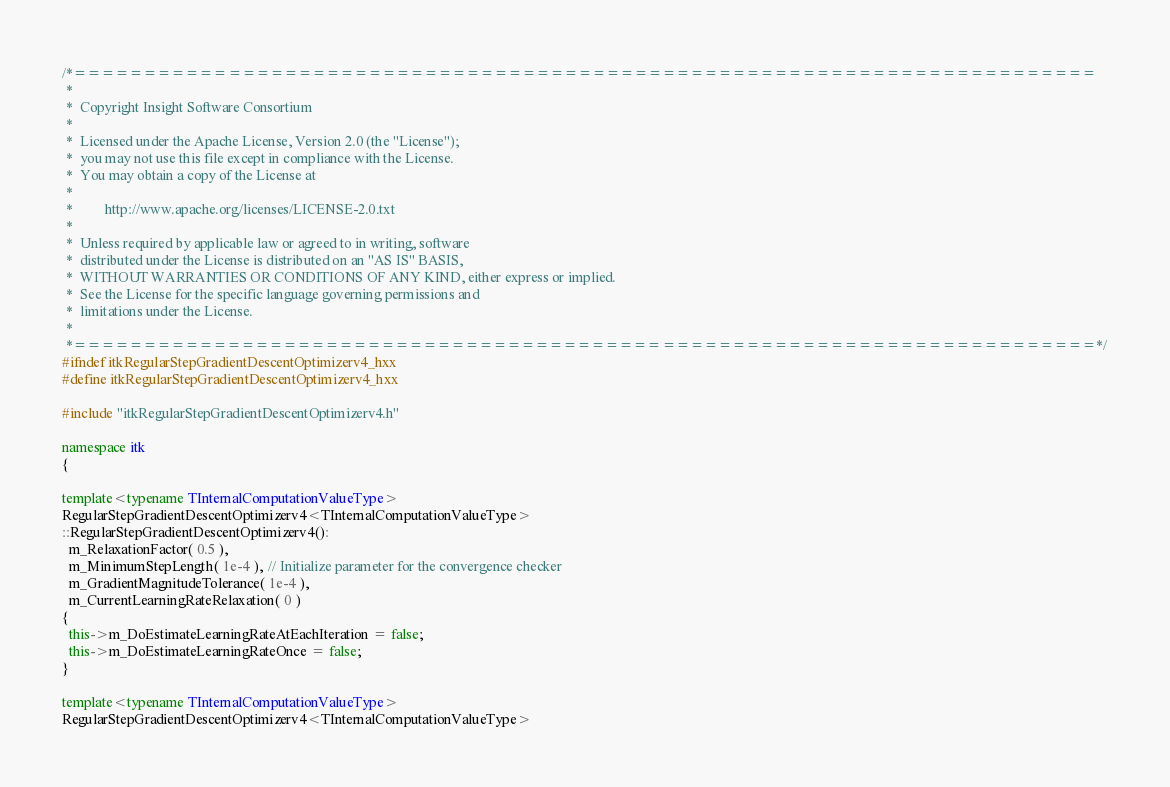Convert code to text. <code><loc_0><loc_0><loc_500><loc_500><_C++_>/*=========================================================================
 *
 *  Copyright Insight Software Consortium
 *
 *  Licensed under the Apache License, Version 2.0 (the "License");
 *  you may not use this file except in compliance with the License.
 *  You may obtain a copy of the License at
 *
 *         http://www.apache.org/licenses/LICENSE-2.0.txt
 *
 *  Unless required by applicable law or agreed to in writing, software
 *  distributed under the License is distributed on an "AS IS" BASIS,
 *  WITHOUT WARRANTIES OR CONDITIONS OF ANY KIND, either express or implied.
 *  See the License for the specific language governing permissions and
 *  limitations under the License.
 *
 *=========================================================================*/
#ifndef itkRegularStepGradientDescentOptimizerv4_hxx
#define itkRegularStepGradientDescentOptimizerv4_hxx

#include "itkRegularStepGradientDescentOptimizerv4.h"

namespace itk
{

template<typename TInternalComputationValueType>
RegularStepGradientDescentOptimizerv4<TInternalComputationValueType>
::RegularStepGradientDescentOptimizerv4():
  m_RelaxationFactor( 0.5 ),
  m_MinimumStepLength( 1e-4 ), // Initialize parameter for the convergence checker
  m_GradientMagnitudeTolerance( 1e-4 ),
  m_CurrentLearningRateRelaxation( 0 )
{
  this->m_DoEstimateLearningRateAtEachIteration = false;
  this->m_DoEstimateLearningRateOnce = false;
}

template<typename TInternalComputationValueType>
RegularStepGradientDescentOptimizerv4<TInternalComputationValueType></code> 